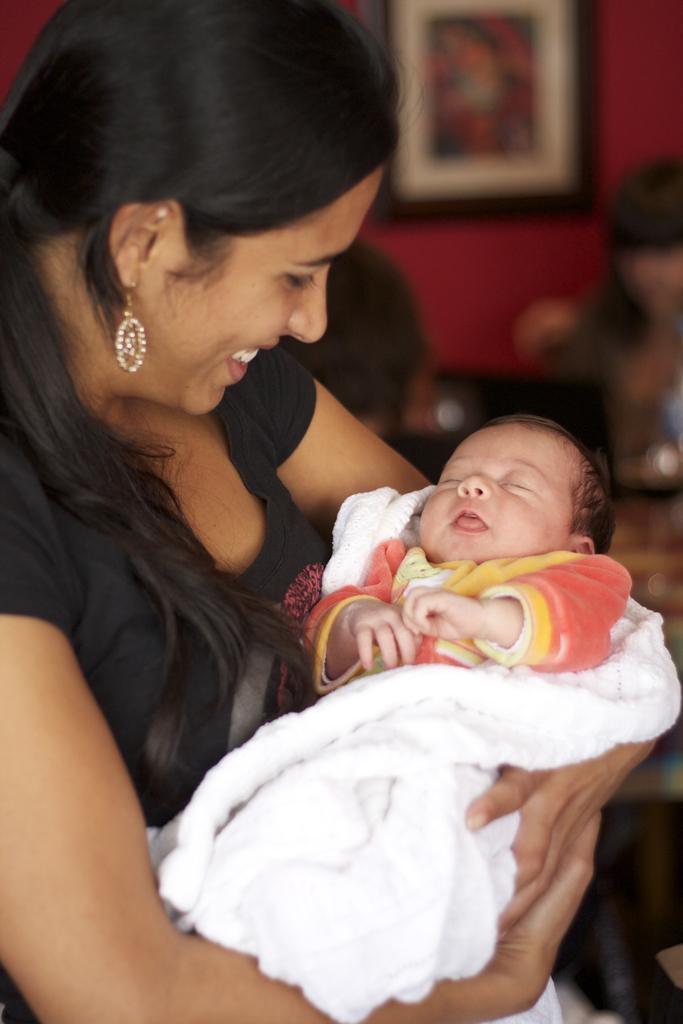In one or two sentences, can you explain what this image depicts? In this image I can see a woman in the font and I can see she is holding a baby. I can also see she is wearing black dress and under the baby I can see a white cloth. In the background I can see two persons and a frame on the wall. I can also see this image is little bit blurry in the background and in the front I can see smile on the woman's face. 